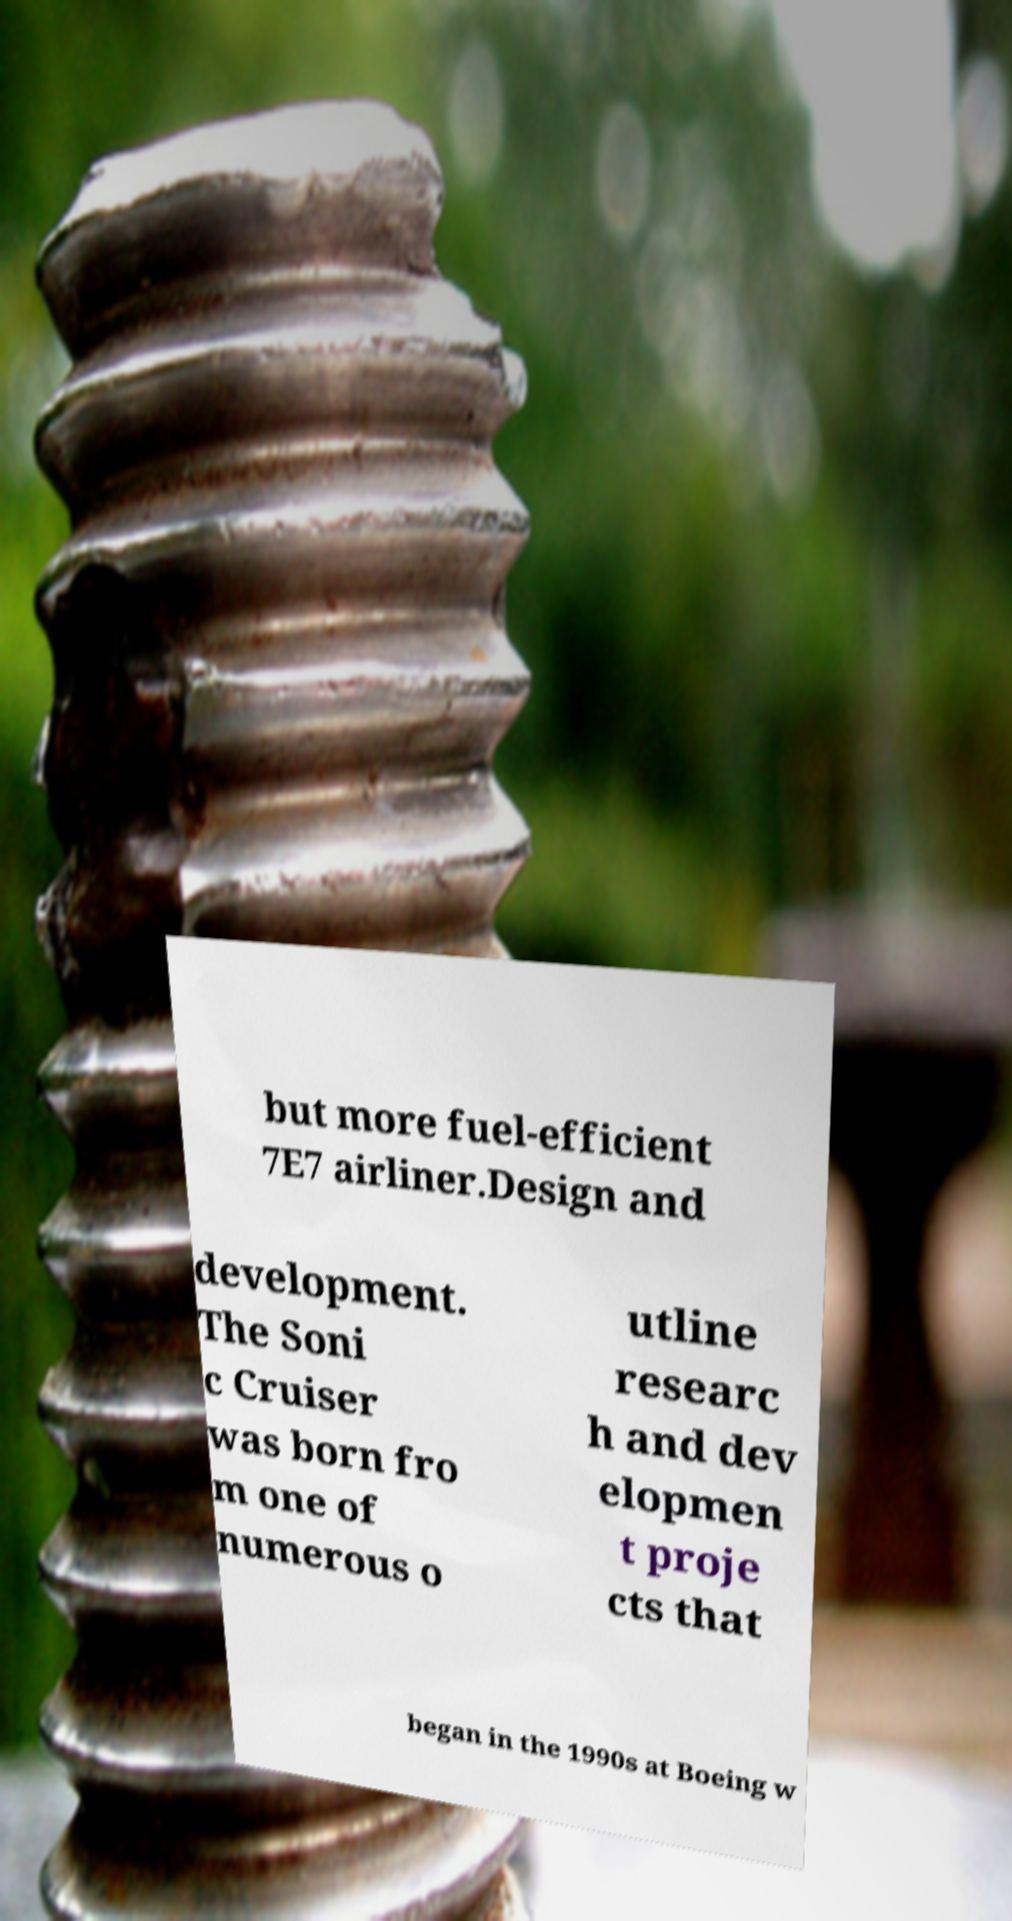Can you read and provide the text displayed in the image?This photo seems to have some interesting text. Can you extract and type it out for me? but more fuel-efficient 7E7 airliner.Design and development. The Soni c Cruiser was born fro m one of numerous o utline researc h and dev elopmen t proje cts that began in the 1990s at Boeing w 